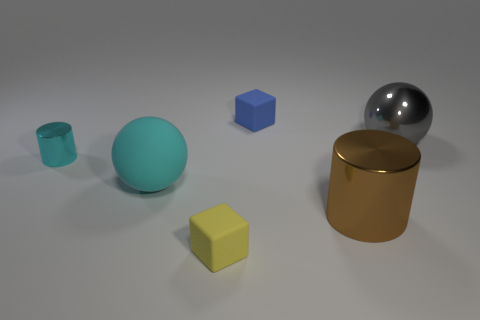What color is the big thing that is to the left of the large cylinder?
Ensure brevity in your answer.  Cyan. Is the size of the cube that is in front of the small cyan shiny cylinder the same as the sphere on the right side of the blue matte object?
Ensure brevity in your answer.  No. Are there any blocks of the same size as the blue rubber thing?
Provide a short and direct response. Yes. What number of big gray metallic things are in front of the cylinder that is to the left of the small yellow rubber cube?
Offer a terse response. 0. What is the material of the yellow thing?
Provide a short and direct response. Rubber. What number of cyan shiny cylinders are behind the brown metal thing?
Ensure brevity in your answer.  1. Is the small metal cylinder the same color as the rubber sphere?
Offer a very short reply. Yes. How many other small cylinders are the same color as the small shiny cylinder?
Ensure brevity in your answer.  0. Is the number of big gray things greater than the number of small green blocks?
Offer a terse response. Yes. There is a metal object that is both right of the yellow rubber thing and to the left of the gray object; what size is it?
Give a very brief answer. Large. 